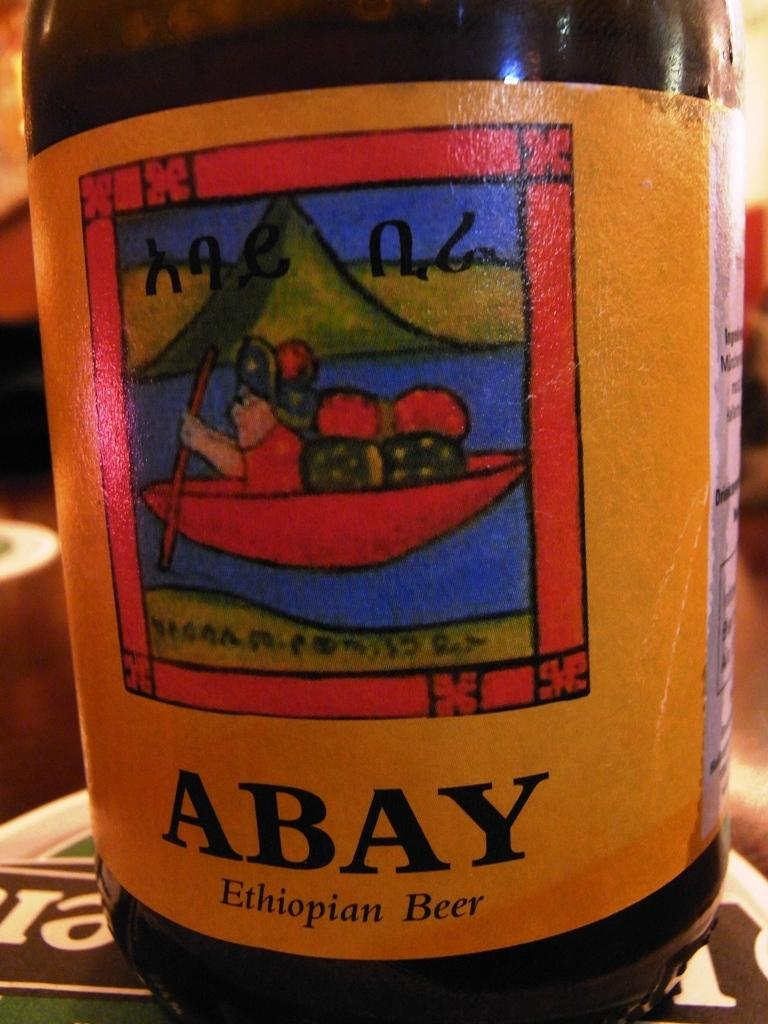<image>
Give a short and clear explanation of the subsequent image. a craft beer that is made in ethiopia with a yellow label 